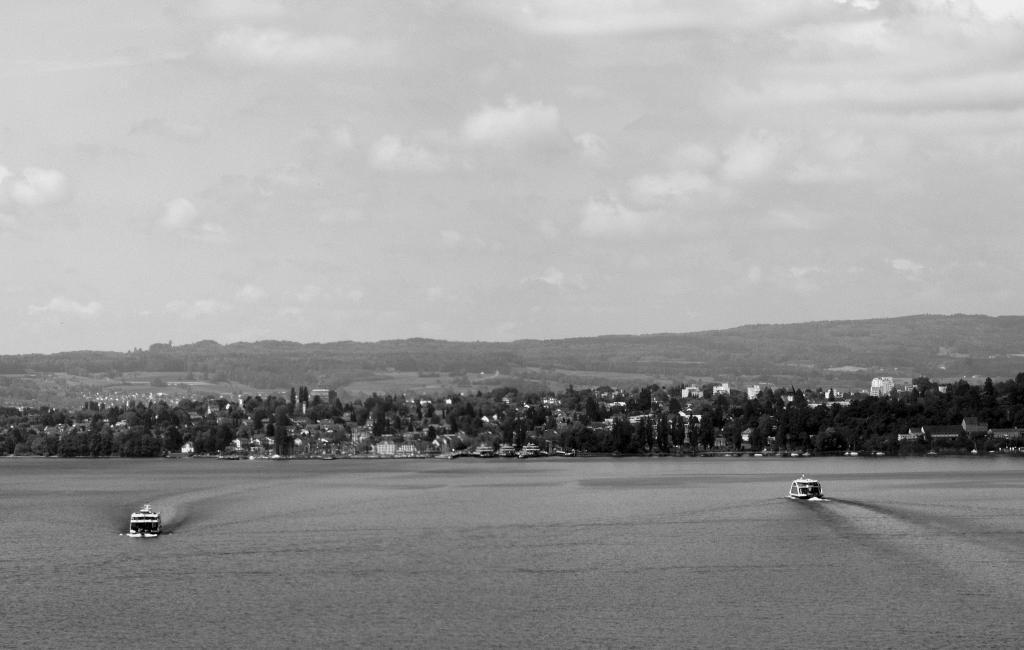How would you summarize this image in a sentence or two? It is a black and white picture. In this picture we can see two boats sailing on the water. We can also see some buildings and trees. In the background we can see mountains and sky. 